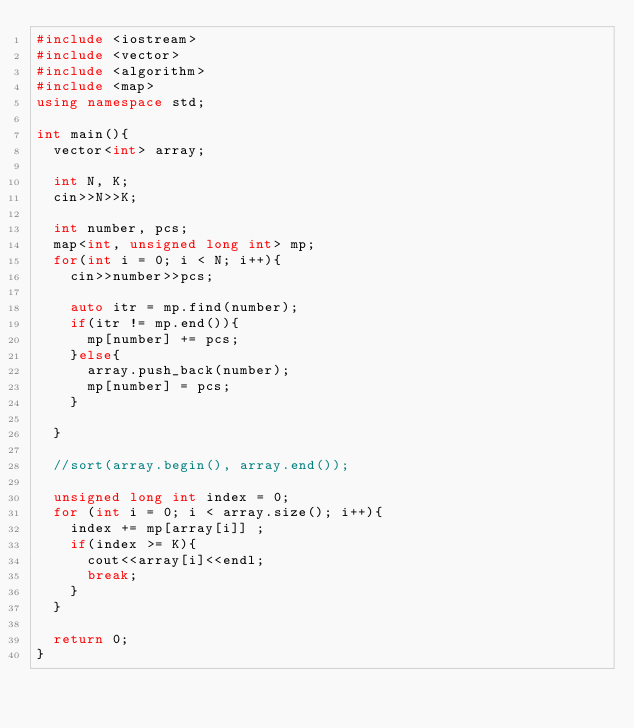<code> <loc_0><loc_0><loc_500><loc_500><_C++_>#include <iostream>
#include <vector>
#include <algorithm>
#include <map>
using namespace std;

int main(){
  vector<int> array;

  int N, K;
  cin>>N>>K;
  
  int number, pcs; 
  map<int, unsigned long int> mp;
  for(int i = 0; i < N; i++){
    cin>>number>>pcs;

    auto itr = mp.find(number);
    if(itr != mp.end()){
      mp[number] += pcs; 
    }else{
      array.push_back(number);
      mp[number] = pcs;
    }

  }

  //sort(array.begin(), array.end());

  unsigned long int index = 0;
  for (int i = 0; i < array.size(); i++){
    index += mp[array[i]] ;
    if(index >= K){
      cout<<array[i]<<endl;
      break;
    }
  }

  return 0;
}
</code> 